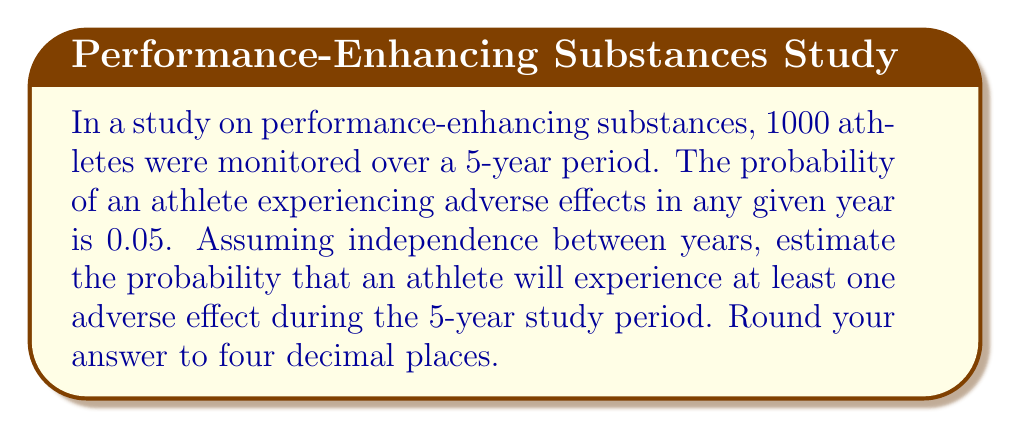Can you solve this math problem? Let's approach this step-by-step:

1) First, we need to understand what the question is asking. We're looking for the probability of at least one adverse effect over 5 years.

2) It's often easier to calculate the probability of the complement event (no adverse effects) and then subtract from 1.

3) The probability of no adverse effects in one year is:
   $1 - 0.05 = 0.95$

4) Assuming independence between years, we can use the multiplication rule of probability. The probability of no adverse effects for all 5 years is:
   $$(0.95)^5 = 0.7738416...$$

5) Therefore, the probability of at least one adverse effect over the 5 years is:
   $$1 - (0.95)^5 = 1 - 0.7738416... = 0.2261584...$$

6) Rounding to four decimal places:
   $0.2261584... \approx 0.2262$

This calculation method is an application of the binomial probability concept, which is fundamental in estimating probabilities for repeated independent trials.
Answer: 0.2262 